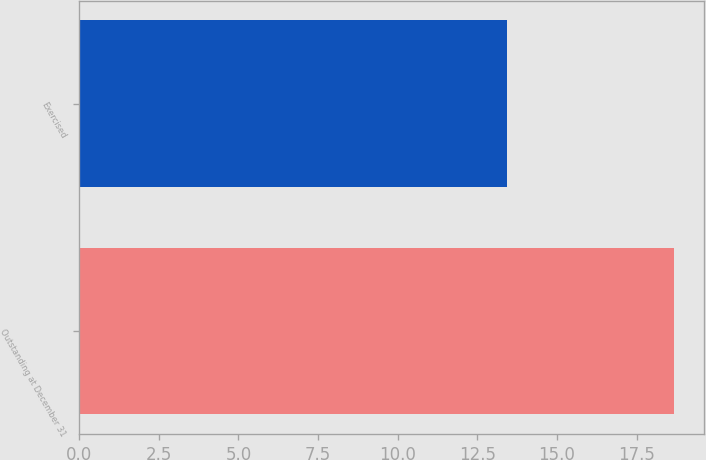Convert chart to OTSL. <chart><loc_0><loc_0><loc_500><loc_500><bar_chart><fcel>Outstanding at December 31<fcel>Exercised<nl><fcel>18.68<fcel>13.43<nl></chart> 